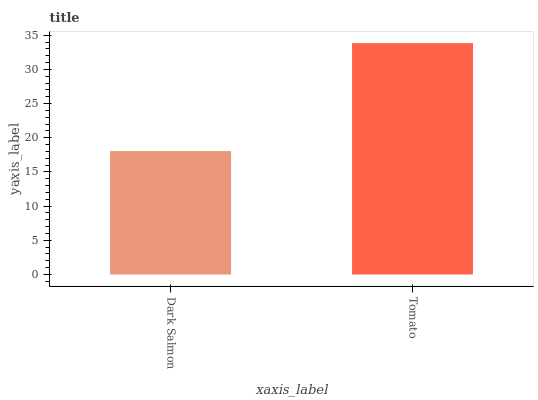Is Dark Salmon the minimum?
Answer yes or no. Yes. Is Tomato the maximum?
Answer yes or no. Yes. Is Tomato the minimum?
Answer yes or no. No. Is Tomato greater than Dark Salmon?
Answer yes or no. Yes. Is Dark Salmon less than Tomato?
Answer yes or no. Yes. Is Dark Salmon greater than Tomato?
Answer yes or no. No. Is Tomato less than Dark Salmon?
Answer yes or no. No. Is Tomato the high median?
Answer yes or no. Yes. Is Dark Salmon the low median?
Answer yes or no. Yes. Is Dark Salmon the high median?
Answer yes or no. No. Is Tomato the low median?
Answer yes or no. No. 